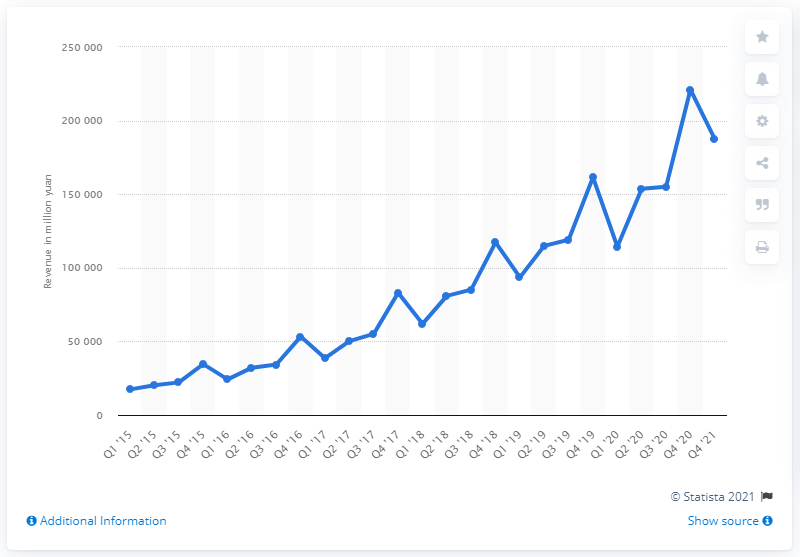Indicate a few pertinent items in this graphic. Alibaba's total revenue in the first quarter of 201X was 187,395... 